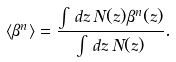Convert formula to latex. <formula><loc_0><loc_0><loc_500><loc_500>\langle \beta ^ { n } \rangle = \frac { \int \, d z \, N ( z ) \beta ^ { n } ( z ) } { \int \, d z \, N ( z ) } .</formula> 